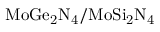Convert formula to latex. <formula><loc_0><loc_0><loc_500><loc_500>M o G e _ { 2 } N _ { 4 } / M o S i _ { 2 } N _ { 4 }</formula> 